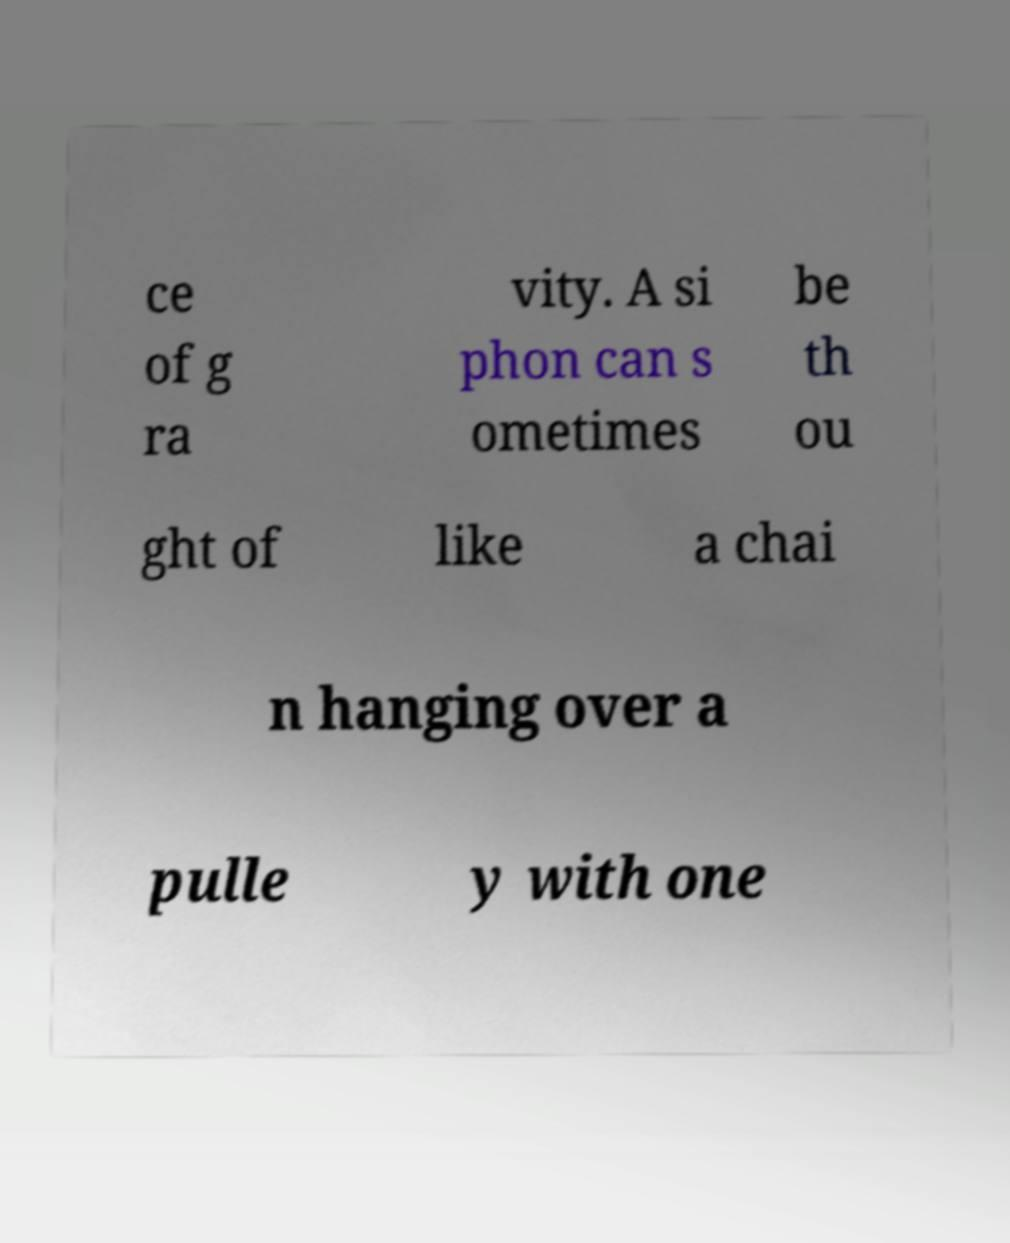Can you read and provide the text displayed in the image?This photo seems to have some interesting text. Can you extract and type it out for me? ce of g ra vity. A si phon can s ometimes be th ou ght of like a chai n hanging over a pulle y with one 